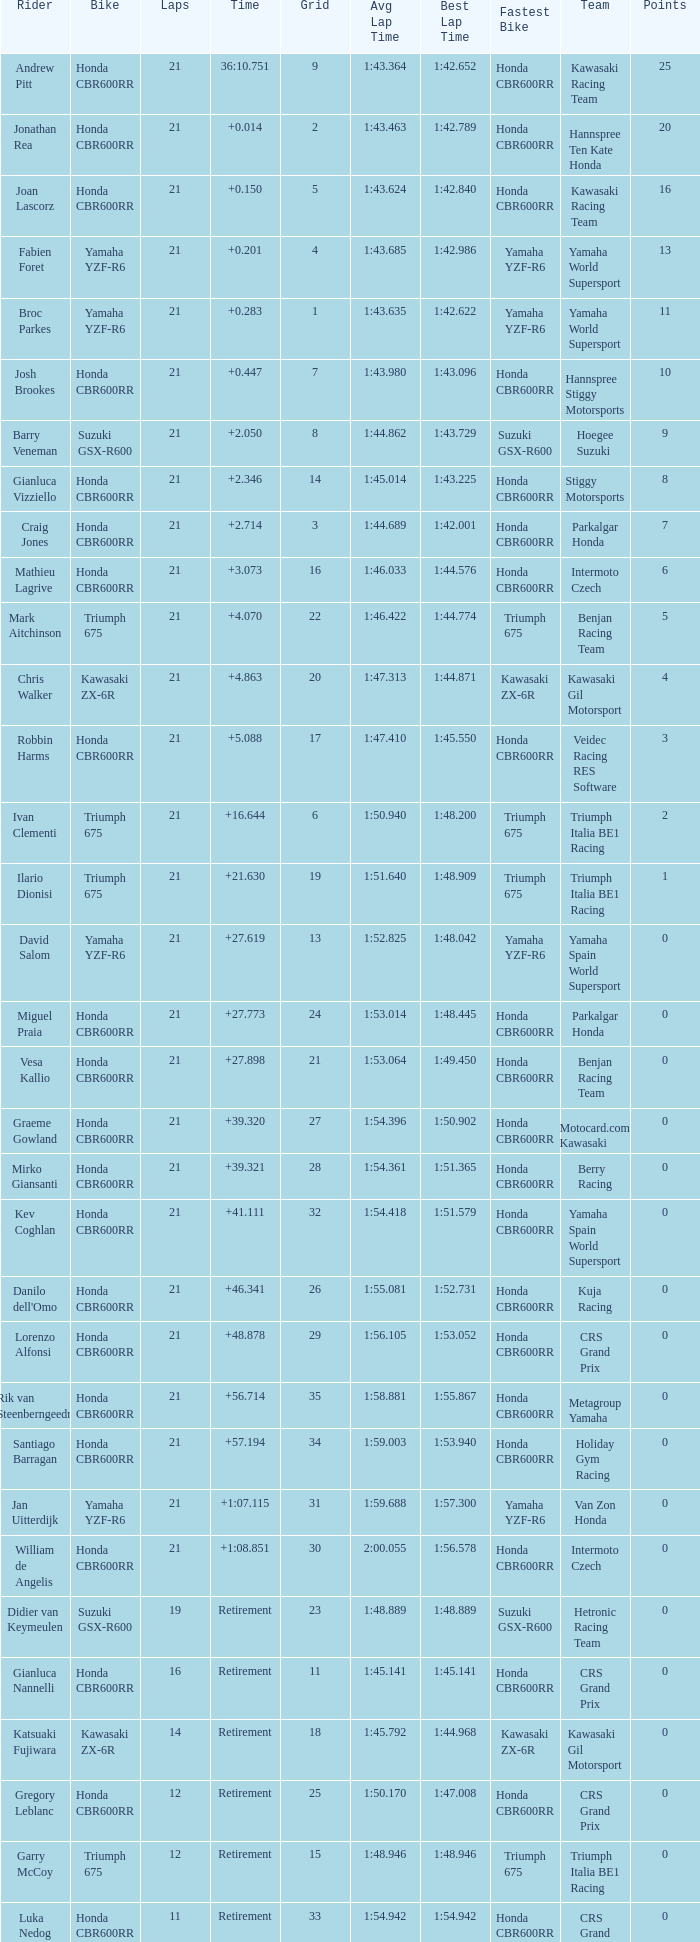What driver had the highest grid position with a time of +0.283? 1.0. 